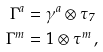<formula> <loc_0><loc_0><loc_500><loc_500>\Gamma ^ { a } & = \gamma ^ { a } \otimes \tau _ { 7 } \\ \Gamma ^ { m } & = 1 \otimes \tau ^ { m } \, ,</formula> 